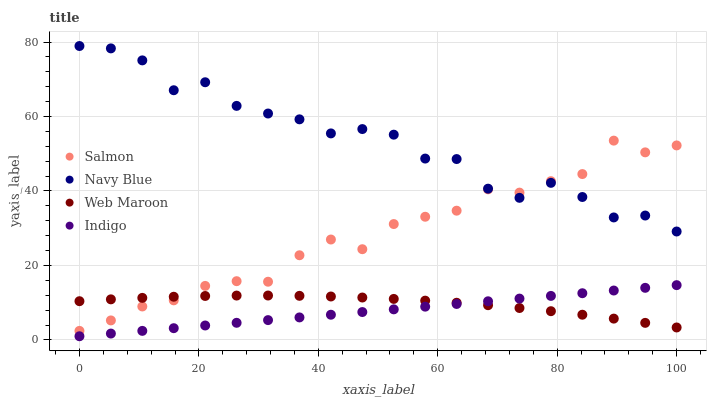Does Indigo have the minimum area under the curve?
Answer yes or no. Yes. Does Navy Blue have the maximum area under the curve?
Answer yes or no. Yes. Does Salmon have the minimum area under the curve?
Answer yes or no. No. Does Salmon have the maximum area under the curve?
Answer yes or no. No. Is Indigo the smoothest?
Answer yes or no. Yes. Is Navy Blue the roughest?
Answer yes or no. Yes. Is Salmon the smoothest?
Answer yes or no. No. Is Salmon the roughest?
Answer yes or no. No. Does Indigo have the lowest value?
Answer yes or no. Yes. Does Salmon have the lowest value?
Answer yes or no. No. Does Navy Blue have the highest value?
Answer yes or no. Yes. Does Salmon have the highest value?
Answer yes or no. No. Is Web Maroon less than Navy Blue?
Answer yes or no. Yes. Is Salmon greater than Indigo?
Answer yes or no. Yes. Does Salmon intersect Web Maroon?
Answer yes or no. Yes. Is Salmon less than Web Maroon?
Answer yes or no. No. Is Salmon greater than Web Maroon?
Answer yes or no. No. Does Web Maroon intersect Navy Blue?
Answer yes or no. No. 